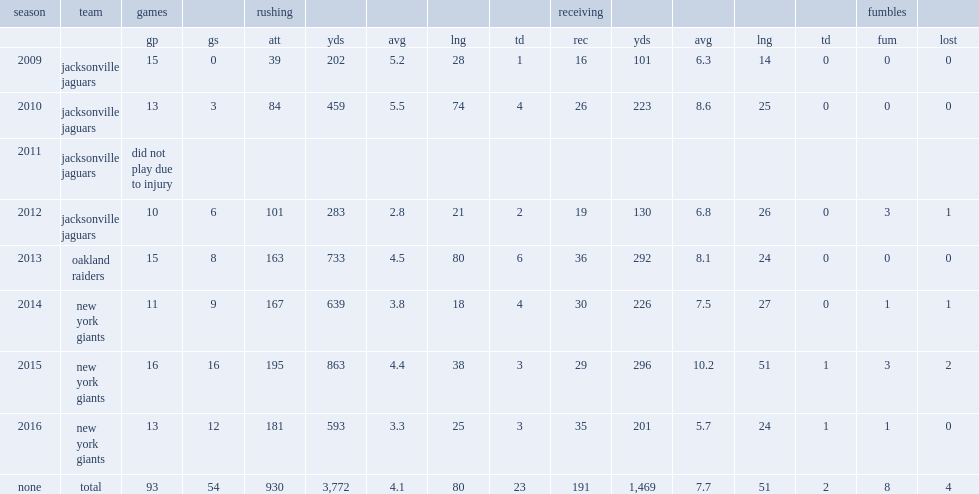Write the full table. {'header': ['season', 'team', 'games', '', 'rushing', '', '', '', '', 'receiving', '', '', '', '', 'fumbles', ''], 'rows': [['', '', 'gp', 'gs', 'att', 'yds', 'avg', 'lng', 'td', 'rec', 'yds', 'avg', 'lng', 'td', 'fum', 'lost'], ['2009', 'jacksonville jaguars', '15', '0', '39', '202', '5.2', '28', '1', '16', '101', '6.3', '14', '0', '0', '0'], ['2010', 'jacksonville jaguars', '13', '3', '84', '459', '5.5', '74', '4', '26', '223', '8.6', '25', '0', '0', '0'], ['2011', 'jacksonville jaguars', 'did not play due to injury', '', '', '', '', '', '', '', '', '', '', '', '', ''], ['2012', 'jacksonville jaguars', '10', '6', '101', '283', '2.8', '21', '2', '19', '130', '6.8', '26', '0', '3', '1'], ['2013', 'oakland raiders', '15', '8', '163', '733', '4.5', '80', '6', '36', '292', '8.1', '24', '0', '0', '0'], ['2014', 'new york giants', '11', '9', '167', '639', '3.8', '18', '4', '30', '226', '7.5', '27', '0', '1', '1'], ['2015', 'new york giants', '16', '16', '195', '863', '4.4', '38', '3', '29', '296', '10.2', '51', '1', '3', '2'], ['2016', 'new york giants', '13', '12', '181', '593', '3.3', '25', '3', '35', '201', '5.7', '24', '1', '1', '0'], ['none', 'total', '93', '54', '930', '3,772', '4.1', '80', '23', '191', '1,469', '7.7', '51', '2', '8', '4']]} How many receptions did jennings get in 2015. 29.0. 